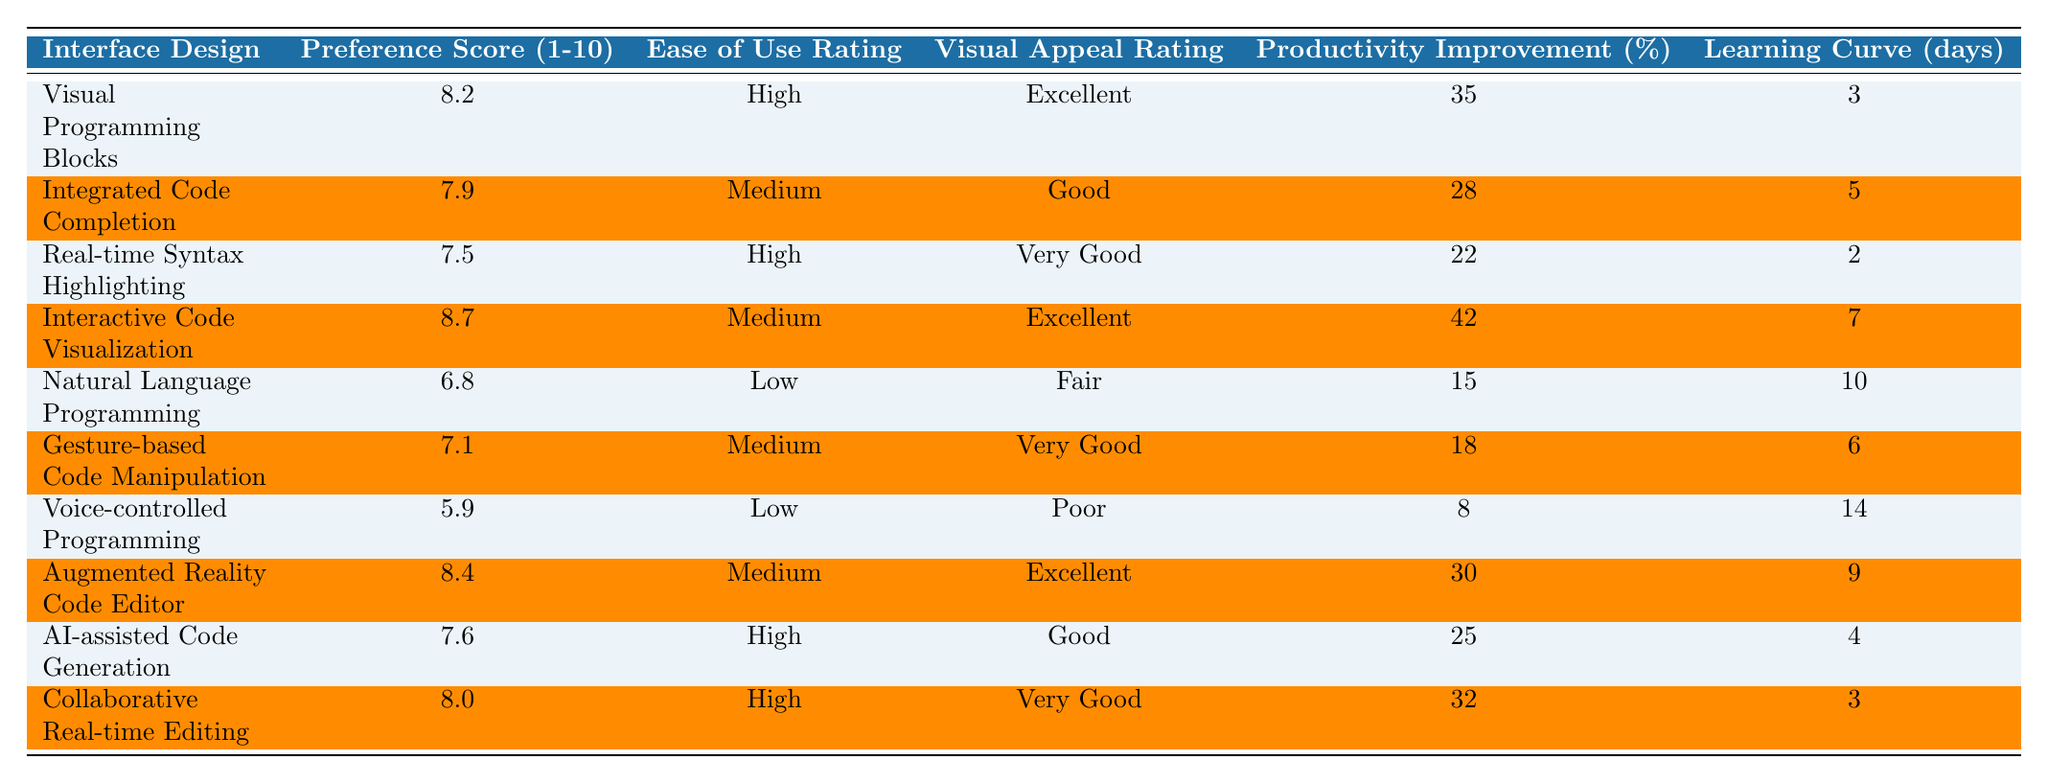What is the highest Preference Score among the interface designs? The highest Preference Score listed in the table is 8.7 for Interactive Code Visualization.
Answer: 8.7 Which interface design has a Low Ease of Use Rating? There are two interface designs with a Low Ease of Use Rating: Natural Language Programming and Voice-controlled Programming.
Answer: Natural Language Programming, Voice-controlled Programming What is the average Productivity Improvement of all the interface designs? To find the average, we sum the Productivity Improvement values: (35 + 28 + 22 + 42 + 15 + 18 + 8 + 30 + 25 + 32) =  285. There are 10 interface designs, so the average is 285/10 = 28.5.
Answer: 28.5 How many interface designs scored higher than 8 for Preference Score? The interface designs that scored higher than 8 are Visual Programming Blocks, Interactive Code Visualization, and Augmented Reality Code Editor, making a total of three designs.
Answer: 3 Is the Visual Appeal Rating for Voice-controlled Programming Poor? Yes, according to the table, the Visual Appeal Rating for Voice-controlled Programming is Poor.
Answer: Yes What is the total Learning Curve in days for all the interface designs combined? To calculate the total Learning Curve, we sum the Learning Curve values: (3 + 5 + 2 + 7 + 10 + 6 + 14 + 9 + 4 + 3) = 63.
Answer: 63 Which interface design has the highest Productivity Improvement and what is that percentage? The interface design with the highest Productivity Improvement is Interactive Code Visualization with a score of 42%.
Answer: Interactive Code Visualization, 42% Is the Ease of Use Rating for Augmented Reality Code Editor considered High? No, the Ease of Use Rating for Augmented Reality Code Editor is Medium.
Answer: No What is the difference between the highest and lowest Preference Scores? The highest Preference Score is 8.7 (Interactive Code Visualization) and the lowest is 5.9 (Voice-controlled Programming). The difference is 8.7 - 5.9 = 2.8.
Answer: 2.8 Which interface design has the least Learning Curve in days? Real-time Syntax Highlighting has the least Learning Curve of 2 days.
Answer: Real-time Syntax Highlighting 